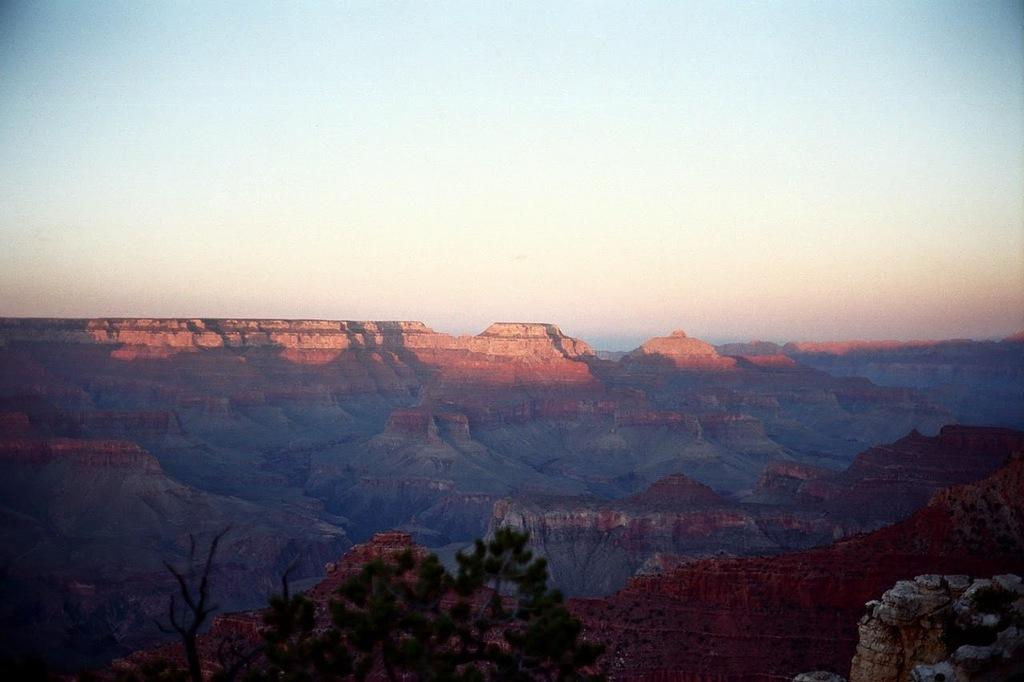What type of natural formation can be seen in the image? There are hills in the image. What type of vegetation is present in the image? There are leaves and branches visible in the image. What is visible in the background of the image? The sky is visible in the background of the image. How many geese are flying over the hills in the image? There are no geese present in the image. What type of border is visible around the image? The image does not have a border; it is a photograph or illustration of a scene. 